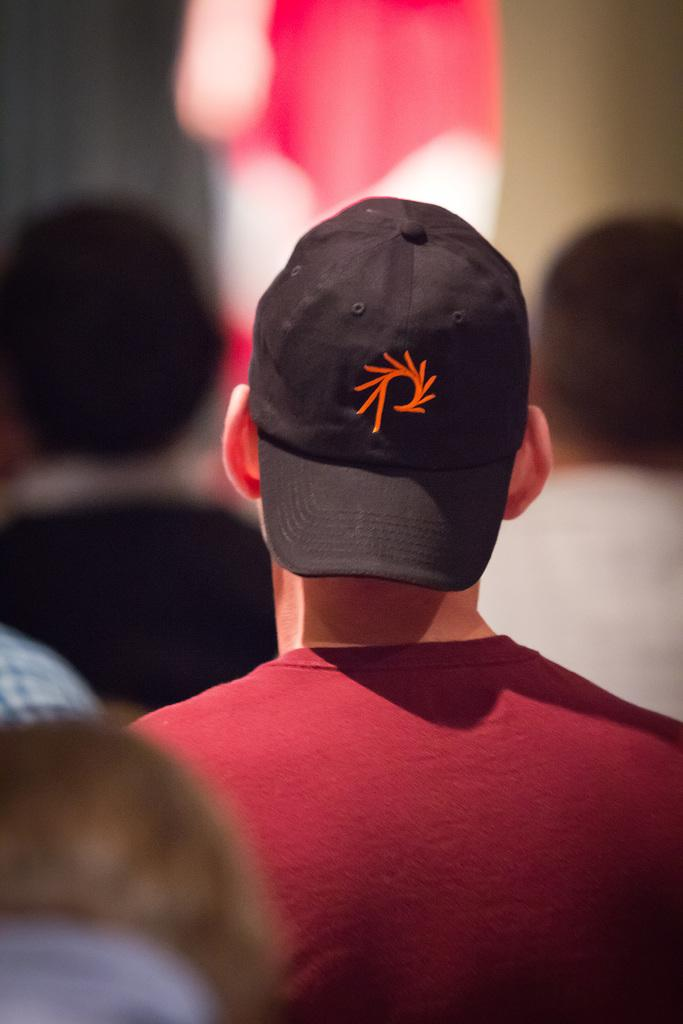Who or what is the main subject in the image? There is a person in the image. What is the person wearing on their upper body? The person is wearing a dark red t-shirt. What type of headwear is the person wearing? The person is wearing a black cap. What type of hole can be seen in the person's t-shirt in the image? There is no hole visible in the person's t-shirt in the image. Is the person in the image located in a hospital? There is no indication of a hospital setting in the image. 